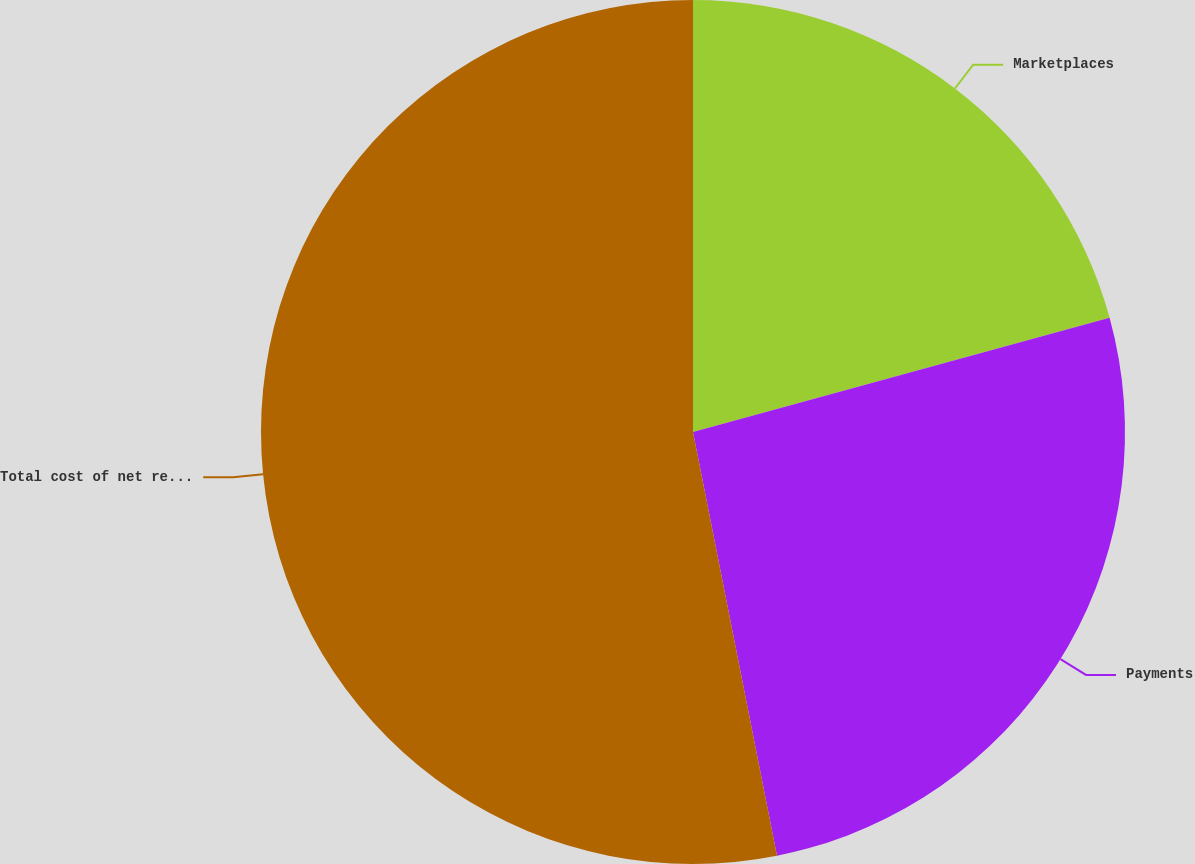Convert chart to OTSL. <chart><loc_0><loc_0><loc_500><loc_500><pie_chart><fcel>Marketplaces<fcel>Payments<fcel>Total cost of net revenues<nl><fcel>20.74%<fcel>26.15%<fcel>53.12%<nl></chart> 